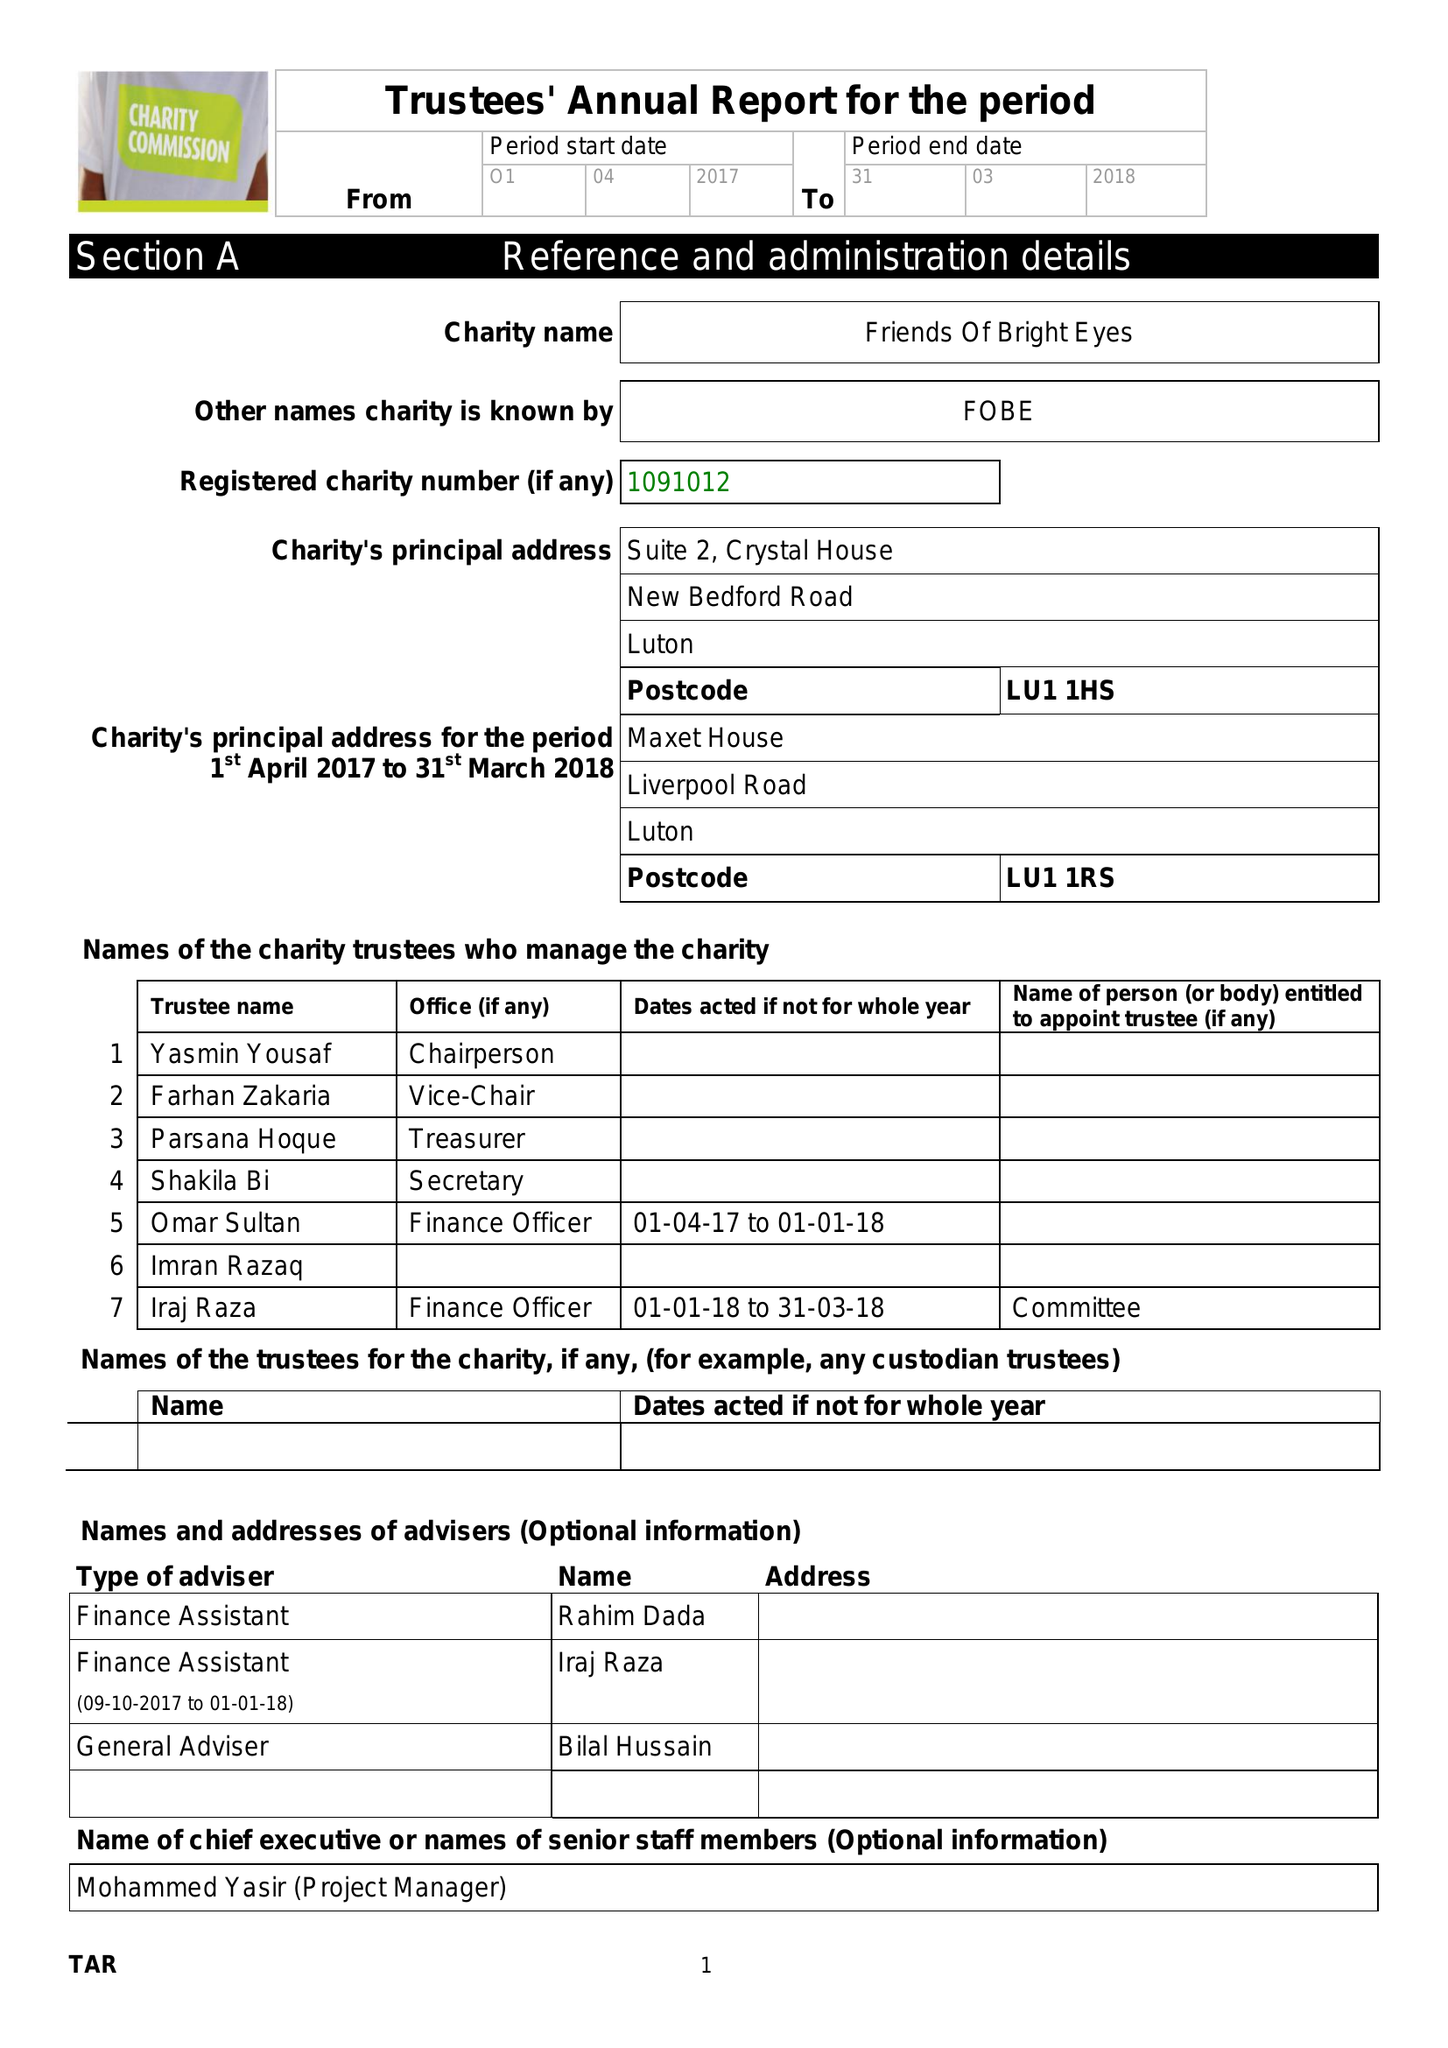What is the value for the address__postcode?
Answer the question using a single word or phrase. LU1 1HS 